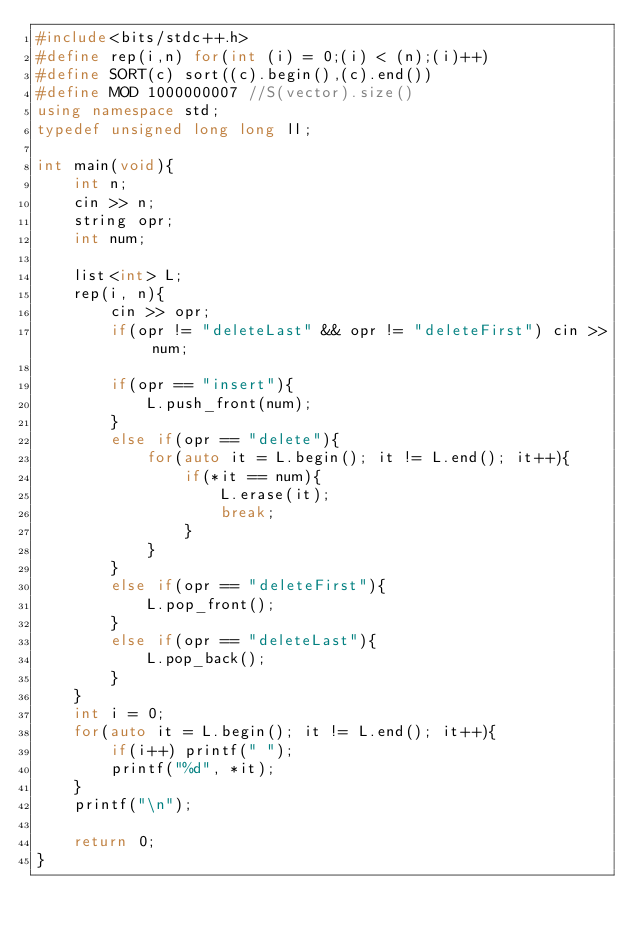Convert code to text. <code><loc_0><loc_0><loc_500><loc_500><_C++_>#include<bits/stdc++.h>
#define rep(i,n) for(int (i) = 0;(i) < (n);(i)++)
#define SORT(c) sort((c).begin(),(c).end())
#define MOD 1000000007 //S(vector).size()
using namespace std;
typedef unsigned long long ll;

int main(void){
	int n;
	cin >> n;
	string opr;
	int num;

	list<int> L;
	rep(i, n){
		cin >> opr;
		if(opr != "deleteLast" && opr != "deleteFirst") cin >> num;

		if(opr == "insert"){
			L.push_front(num);
		}
		else if(opr == "delete"){
			for(auto it = L.begin(); it != L.end(); it++){
				if(*it == num){
					L.erase(it);
					break;
				}
			}
		}
		else if(opr == "deleteFirst"){
			L.pop_front();
		}
		else if(opr == "deleteLast"){
			L.pop_back();
		}
	}
	int i = 0;
	for(auto it = L.begin(); it != L.end(); it++){
		if(i++) printf(" ");
		printf("%d", *it);
	}
	printf("\n");

	return 0;
}

</code> 